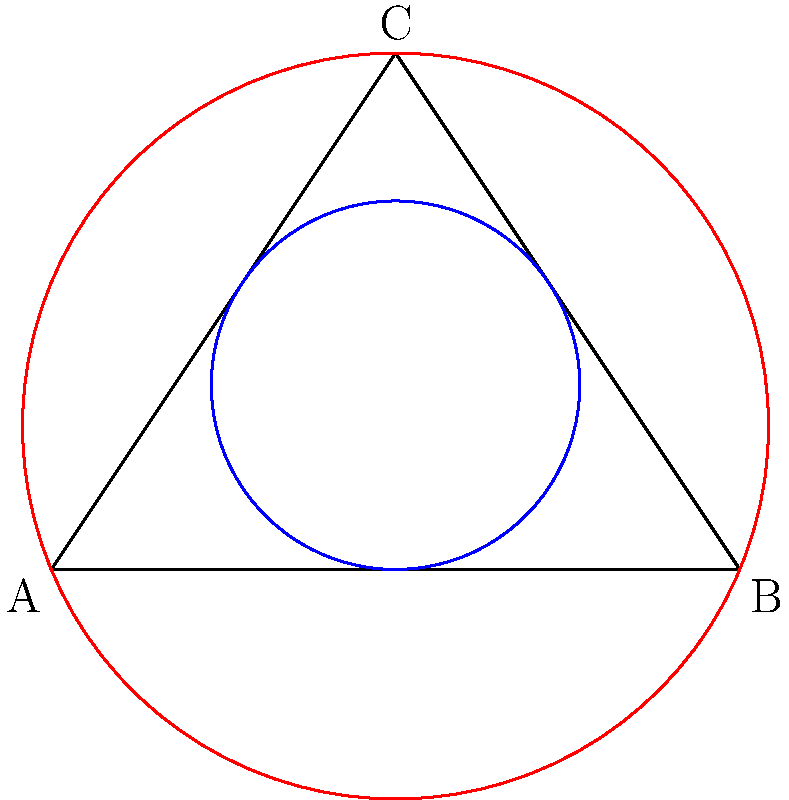In adapting a classic novel for the screen, you're visualizing the relationships between three main characters as a triangle. The inscribed circle represents the common ground they share, while the circumscribed circle represents the overall narrative scope. If the radius of the inscribed circle (r) is 1 unit and the radius of the circumscribed circle (R) is 2.5 units, what is the ratio of the area of the inscribed circle to the area of the circumscribed circle? How might this ratio inform your adaptation strategy? Let's approach this step-by-step:

1) The area of a circle is given by the formula $A = \pi r^2$, where $r$ is the radius.

2) For the inscribed circle:
   $A_i = \pi r^2 = \pi (1)^2 = \pi$

3) For the circumscribed circle:
   $A_c = \pi R^2 = \pi (2.5)^2 = 6.25\pi$

4) The ratio of the areas is:
   $\frac{A_i}{A_c} = \frac{\pi}{6.25\pi} = \frac{1}{6.25} = 0.16$

5) This can be simplified to $\frac{4}{25}$ or $16\%$

Interpretation for adaptation:
This ratio suggests that the common ground (inscribed circle) between the characters is relatively small compared to the overall narrative scope (circumscribed circle). In adaptation, this could mean:

- Focusing on developing individual character arcs more than their interactions
- Expanding the narrative beyond the core relationships to include more subplots or secondary characters
- Emphasizing the characters' differences and conflicts rather than their similarities
- Considering ways to gradually increase the "common ground" throughout the story arc
Answer: $\frac{4}{25}$ or $16\%$ 